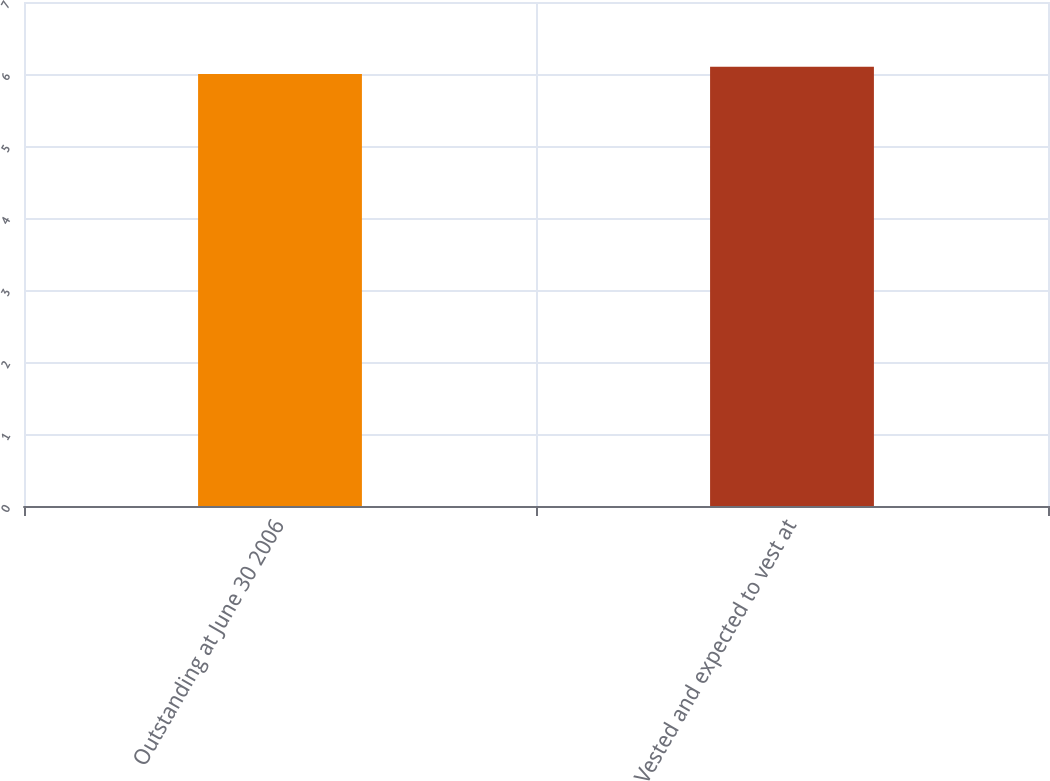Convert chart. <chart><loc_0><loc_0><loc_500><loc_500><bar_chart><fcel>Outstanding at June 30 2006<fcel>Vested and expected to vest at<nl><fcel>6<fcel>6.1<nl></chart> 